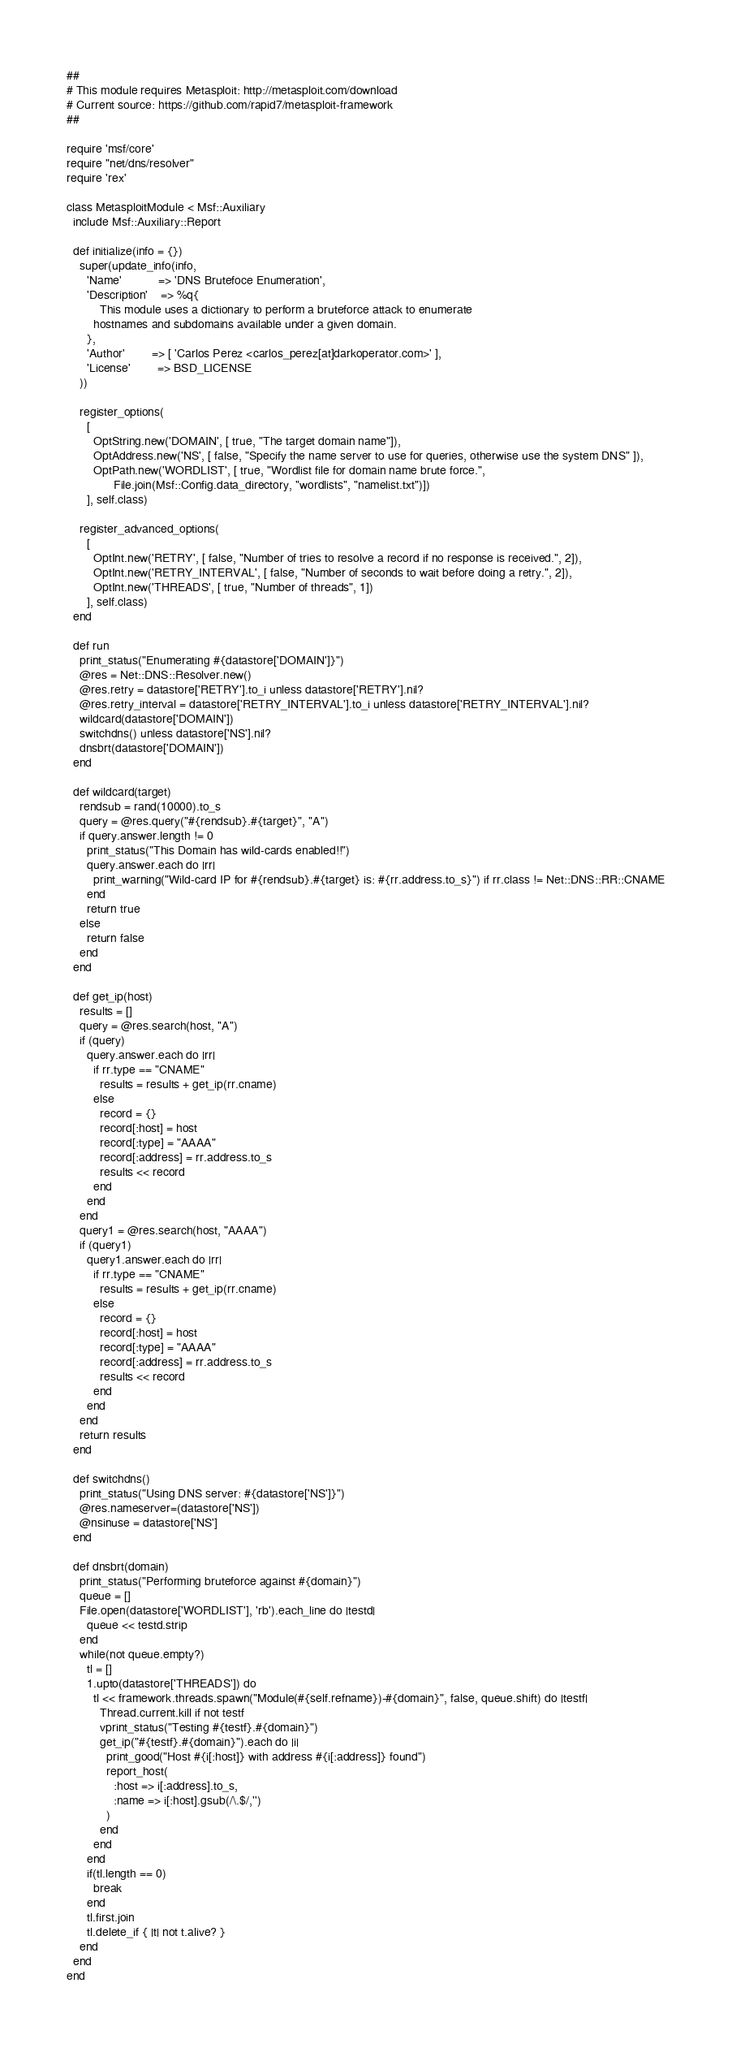Convert code to text. <code><loc_0><loc_0><loc_500><loc_500><_Ruby_>##
# This module requires Metasploit: http://metasploit.com/download
# Current source: https://github.com/rapid7/metasploit-framework
##

require 'msf/core'
require "net/dns/resolver"
require 'rex'

class MetasploitModule < Msf::Auxiliary
  include Msf::Auxiliary::Report

  def initialize(info = {})
    super(update_info(info,
      'Name'		   => 'DNS Brutefoce Enumeration',
      'Description'	=> %q{
          This module uses a dictionary to perform a bruteforce attack to enumerate
        hostnames and subdomains available under a given domain.
      },
      'Author'		=> [ 'Carlos Perez <carlos_perez[at]darkoperator.com>' ],
      'License'		=> BSD_LICENSE
    ))

    register_options(
      [
        OptString.new('DOMAIN', [ true, "The target domain name"]),
        OptAddress.new('NS', [ false, "Specify the name server to use for queries, otherwise use the system DNS" ]),
        OptPath.new('WORDLIST', [ true, "Wordlist file for domain name brute force.",
              File.join(Msf::Config.data_directory, "wordlists", "namelist.txt")])
      ], self.class)

    register_advanced_options(
      [
        OptInt.new('RETRY', [ false, "Number of tries to resolve a record if no response is received.", 2]),
        OptInt.new('RETRY_INTERVAL', [ false, "Number of seconds to wait before doing a retry.", 2]),
        OptInt.new('THREADS', [ true, "Number of threads", 1])
      ], self.class)
  end

  def run
    print_status("Enumerating #{datastore['DOMAIN']}")
    @res = Net::DNS::Resolver.new()
    @res.retry = datastore['RETRY'].to_i unless datastore['RETRY'].nil?
    @res.retry_interval = datastore['RETRY_INTERVAL'].to_i unless datastore['RETRY_INTERVAL'].nil?
    wildcard(datastore['DOMAIN'])
    switchdns() unless datastore['NS'].nil?
    dnsbrt(datastore['DOMAIN'])
  end

  def wildcard(target)
    rendsub = rand(10000).to_s
    query = @res.query("#{rendsub}.#{target}", "A")
    if query.answer.length != 0
      print_status("This Domain has wild-cards enabled!!")
      query.answer.each do |rr|
        print_warning("Wild-card IP for #{rendsub}.#{target} is: #{rr.address.to_s}") if rr.class != Net::DNS::RR::CNAME
      end
      return true
    else
      return false
    end
  end

  def get_ip(host)
    results = []
    query = @res.search(host, "A")
    if (query)
      query.answer.each do |rr|
        if rr.type == "CNAME"
          results = results + get_ip(rr.cname)
        else
          record = {}
          record[:host] = host
          record[:type] = "AAAA"
          record[:address] = rr.address.to_s
          results << record
        end
      end
    end
    query1 = @res.search(host, "AAAA")
    if (query1)
      query1.answer.each do |rr|
        if rr.type == "CNAME"
          results = results + get_ip(rr.cname)
        else
          record = {}
          record[:host] = host
          record[:type] = "AAAA"
          record[:address] = rr.address.to_s
          results << record
        end
      end
    end
    return results
  end

  def switchdns()
    print_status("Using DNS server: #{datastore['NS']}")
    @res.nameserver=(datastore['NS'])
    @nsinuse = datastore['NS']
  end

  def dnsbrt(domain)
    print_status("Performing bruteforce against #{domain}")
    queue = []
    File.open(datastore['WORDLIST'], 'rb').each_line do |testd|
      queue << testd.strip
    end
    while(not queue.empty?)
      tl = []
      1.upto(datastore['THREADS']) do
        tl << framework.threads.spawn("Module(#{self.refname})-#{domain}", false, queue.shift) do |testf|
          Thread.current.kill if not testf
          vprint_status("Testing #{testf}.#{domain}")
          get_ip("#{testf}.#{domain}").each do |i|
            print_good("Host #{i[:host]} with address #{i[:address]} found")
            report_host(
              :host => i[:address].to_s,
              :name => i[:host].gsub(/\.$/,'')
            )
          end
        end
      end
      if(tl.length == 0)
        break
      end
      tl.first.join
      tl.delete_if { |t| not t.alive? }
    end
  end
end

</code> 